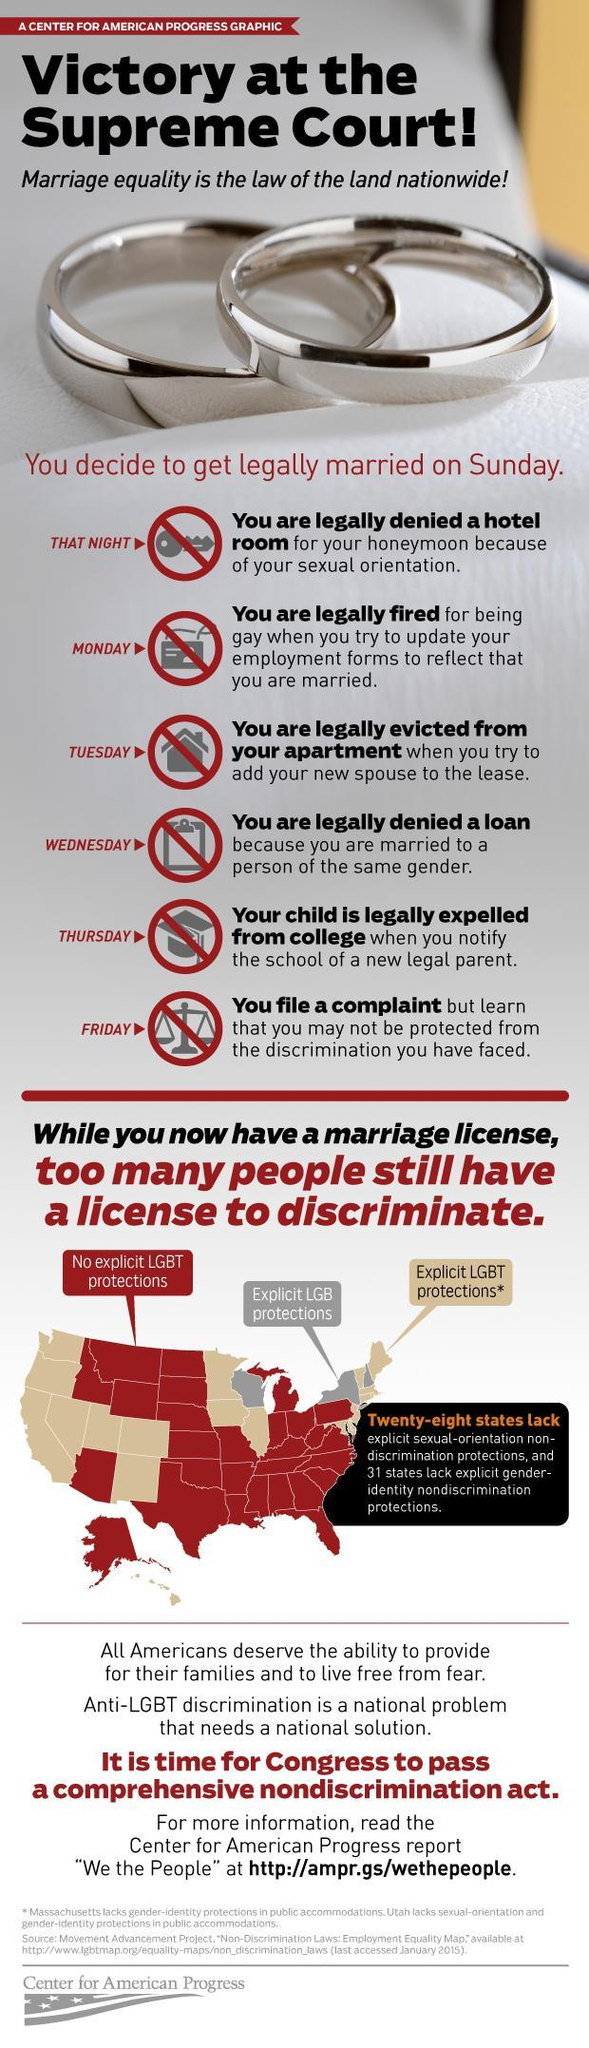How many states in USA lack Explicit LGB protections?
Answer the question with a short phrase. 3 Which day is exempted from the list of marriage day complications- Sunday, Thursday, Saturday, Friday in USA? Saturday Which is the ruling party in USA? Congress How many marriage and law complications in USA are listed in the info graphic? 6 